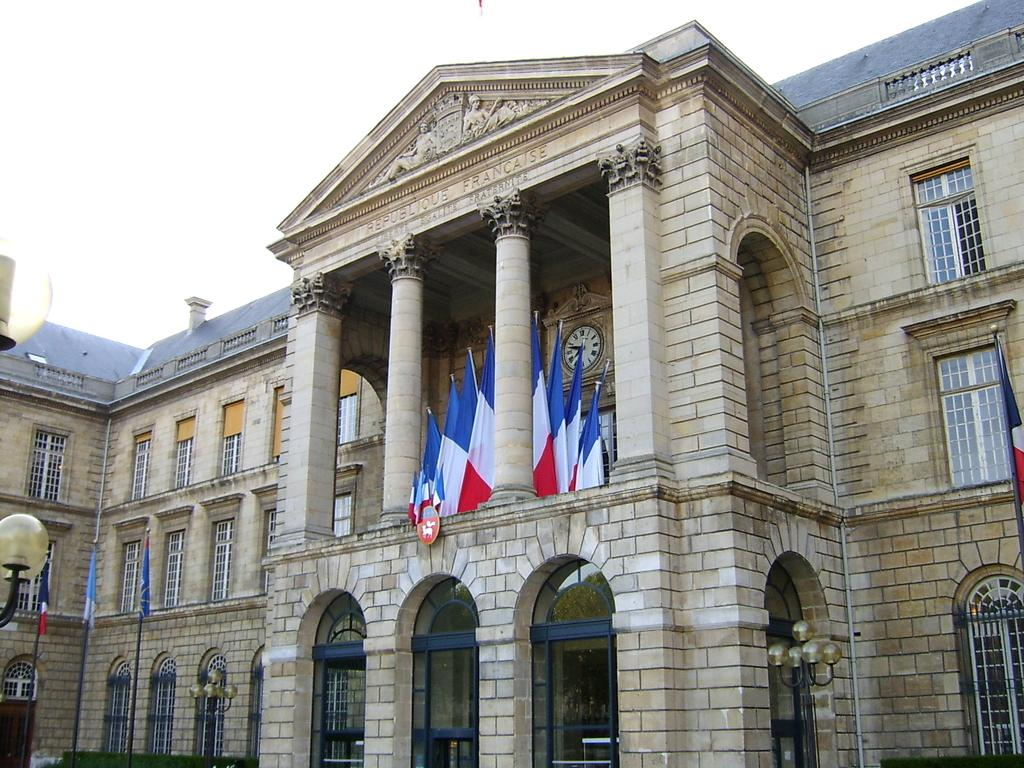What type of structure is present in the image? There is a building in the image. What is attached to the building? Flags and light poles are attached to the building. What type of vegetation can be seen in the image? Grass is visible in the image. What part of the natural environment is visible in the image? The sky is visible in the image. What language are the hands of the people in the image using to communicate? There are no people present in the image, so there is no one using their hands to communicate. 